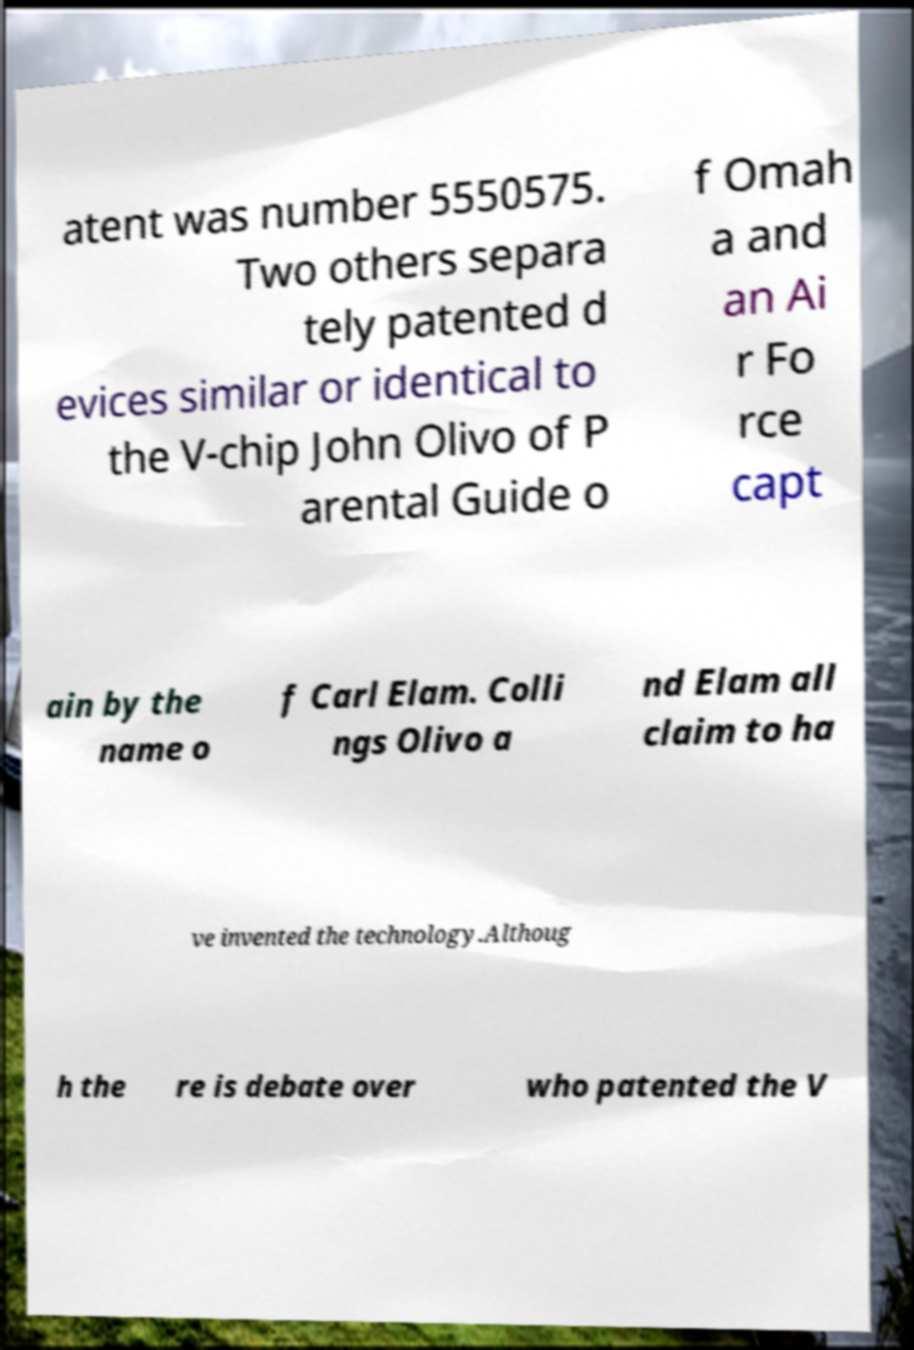Please read and relay the text visible in this image. What does it say? atent was number 5550575. Two others separa tely patented d evices similar or identical to the V-chip John Olivo of P arental Guide o f Omah a and an Ai r Fo rce capt ain by the name o f Carl Elam. Colli ngs Olivo a nd Elam all claim to ha ve invented the technology.Althoug h the re is debate over who patented the V 